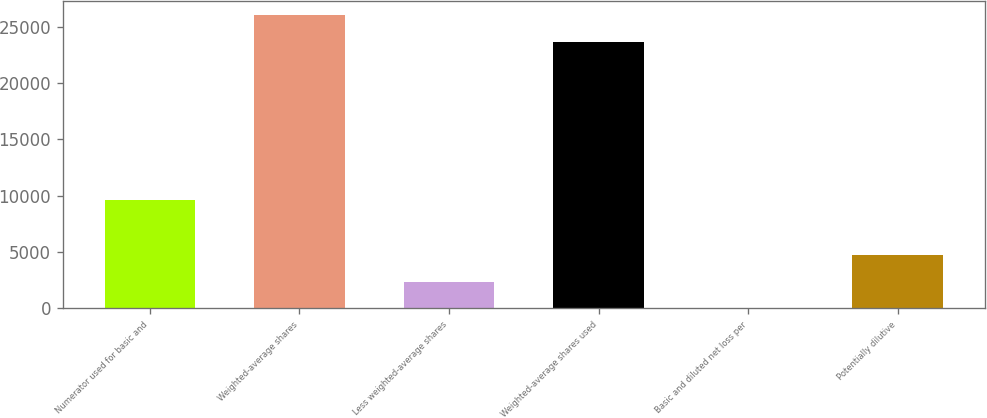Convert chart. <chart><loc_0><loc_0><loc_500><loc_500><bar_chart><fcel>Numerator used for basic and<fcel>Weighted-average shares<fcel>Less weighted-average shares<fcel>Weighted-average shares used<fcel>Basic and diluted net loss per<fcel>Potentially dilutive<nl><fcel>9623<fcel>25989<fcel>2363.37<fcel>23626<fcel>0.41<fcel>4726.33<nl></chart> 